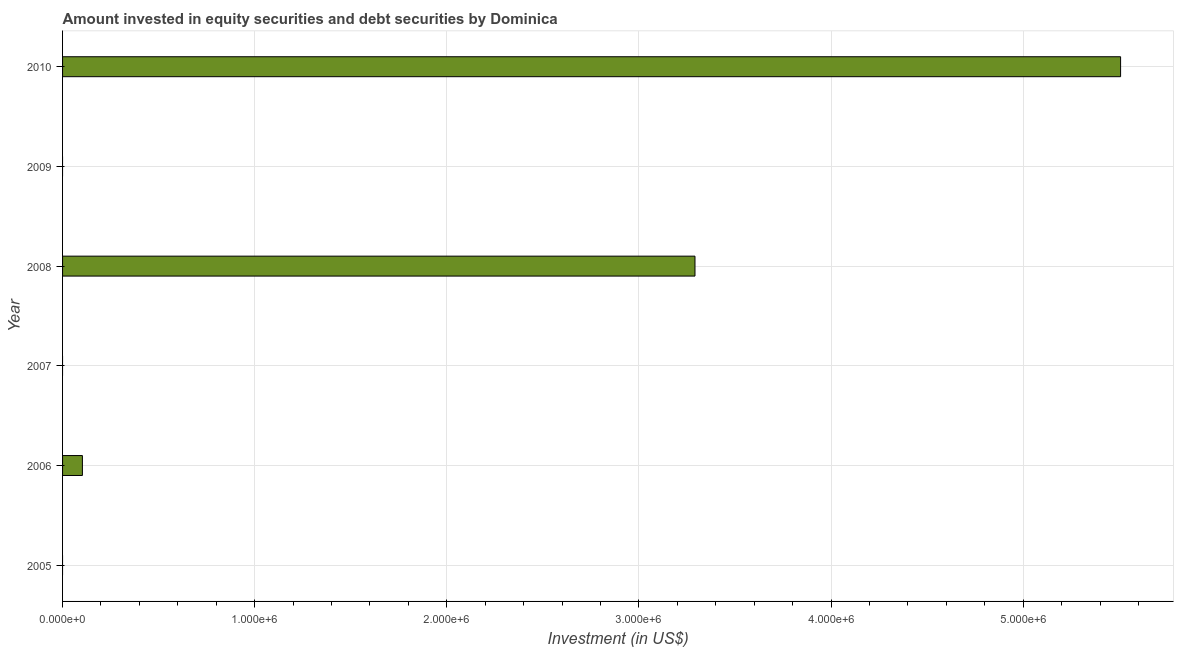Does the graph contain any zero values?
Your response must be concise. Yes. What is the title of the graph?
Offer a terse response. Amount invested in equity securities and debt securities by Dominica. What is the label or title of the X-axis?
Give a very brief answer. Investment (in US$). What is the portfolio investment in 2010?
Keep it short and to the point. 5.51e+06. Across all years, what is the maximum portfolio investment?
Keep it short and to the point. 5.51e+06. What is the sum of the portfolio investment?
Provide a short and direct response. 8.90e+06. What is the difference between the portfolio investment in 2008 and 2010?
Your answer should be very brief. -2.22e+06. What is the average portfolio investment per year?
Give a very brief answer. 1.48e+06. What is the median portfolio investment?
Ensure brevity in your answer.  5.16e+04. What is the ratio of the portfolio investment in 2008 to that in 2010?
Provide a succinct answer. 0.6. Is the portfolio investment in 2006 less than that in 2010?
Ensure brevity in your answer.  Yes. What is the difference between the highest and the second highest portfolio investment?
Give a very brief answer. 2.22e+06. What is the difference between the highest and the lowest portfolio investment?
Offer a very short reply. 5.51e+06. How many bars are there?
Offer a very short reply. 3. What is the difference between two consecutive major ticks on the X-axis?
Your answer should be compact. 1.00e+06. Are the values on the major ticks of X-axis written in scientific E-notation?
Your answer should be compact. Yes. What is the Investment (in US$) in 2006?
Ensure brevity in your answer.  1.03e+05. What is the Investment (in US$) of 2007?
Keep it short and to the point. 0. What is the Investment (in US$) of 2008?
Ensure brevity in your answer.  3.29e+06. What is the Investment (in US$) of 2010?
Offer a terse response. 5.51e+06. What is the difference between the Investment (in US$) in 2006 and 2008?
Make the answer very short. -3.19e+06. What is the difference between the Investment (in US$) in 2006 and 2010?
Ensure brevity in your answer.  -5.40e+06. What is the difference between the Investment (in US$) in 2008 and 2010?
Ensure brevity in your answer.  -2.22e+06. What is the ratio of the Investment (in US$) in 2006 to that in 2008?
Offer a terse response. 0.03. What is the ratio of the Investment (in US$) in 2006 to that in 2010?
Your answer should be very brief. 0.02. What is the ratio of the Investment (in US$) in 2008 to that in 2010?
Your answer should be compact. 0.6. 